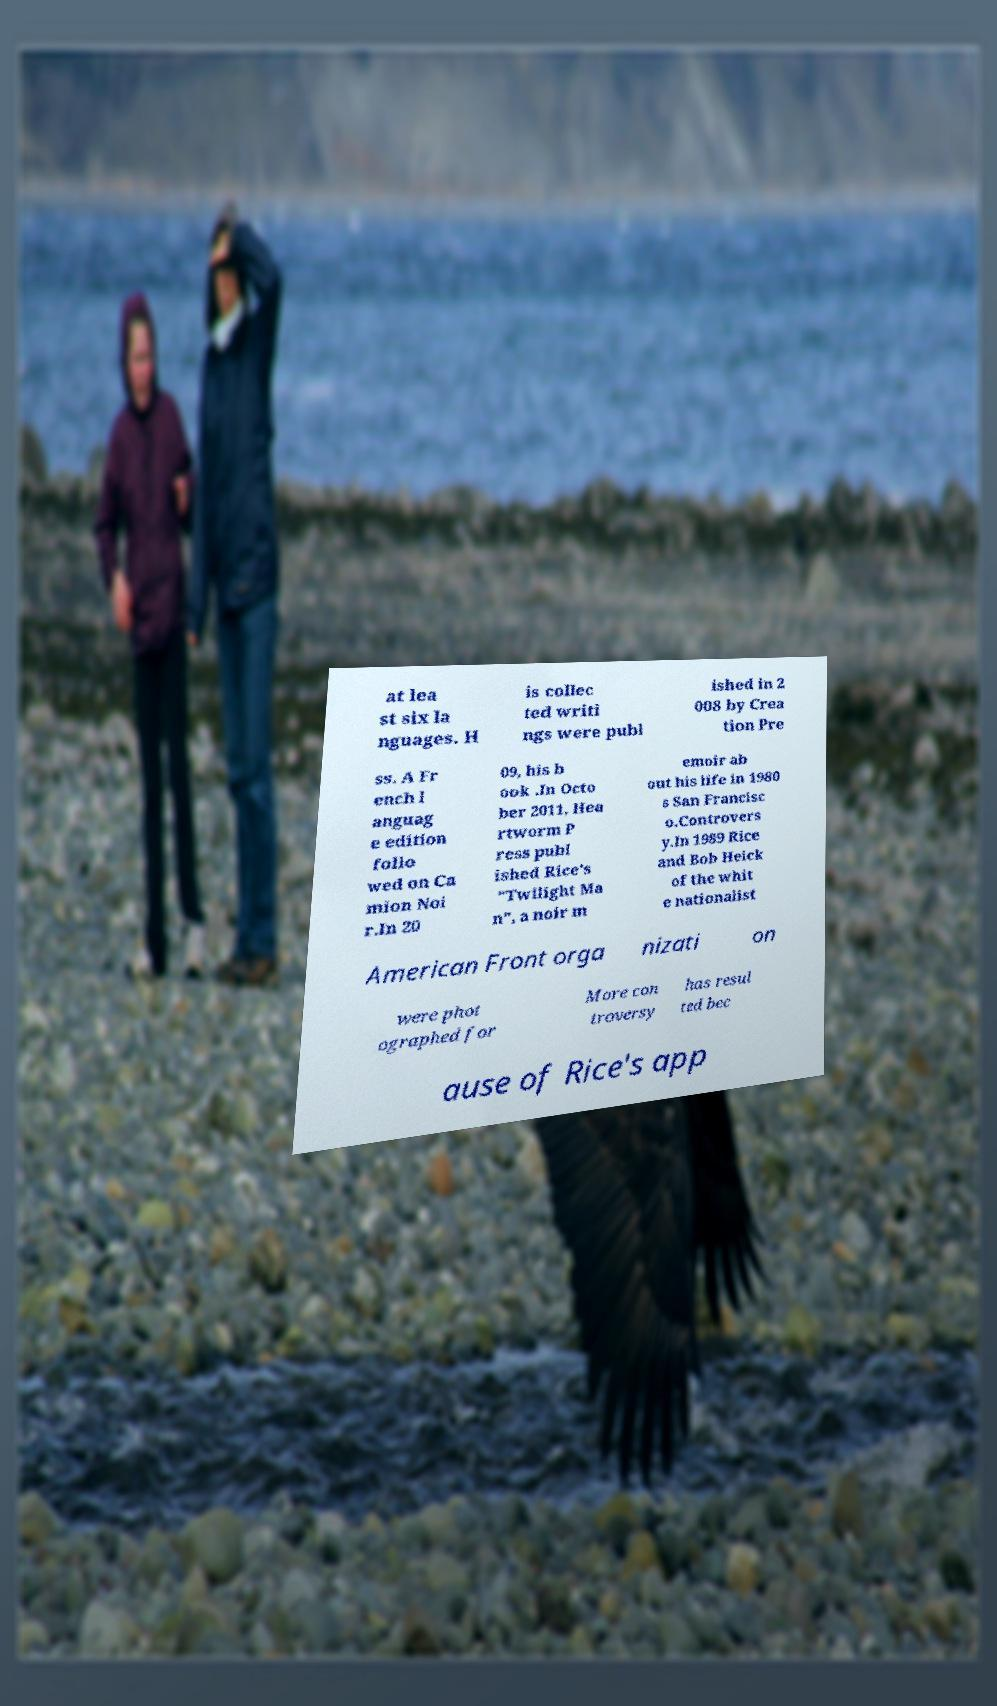Can you accurately transcribe the text from the provided image for me? at lea st six la nguages. H is collec ted writi ngs were publ ished in 2 008 by Crea tion Pre ss. A Fr ench l anguag e edition follo wed on Ca mion Noi r.In 20 09, his b ook .In Octo ber 2011, Hea rtworm P ress publ ished Rice's "Twilight Ma n", a noir m emoir ab out his life in 1980 s San Francisc o.Controvers y.In 1989 Rice and Bob Heick of the whit e nationalist American Front orga nizati on were phot ographed for More con troversy has resul ted bec ause of Rice's app 